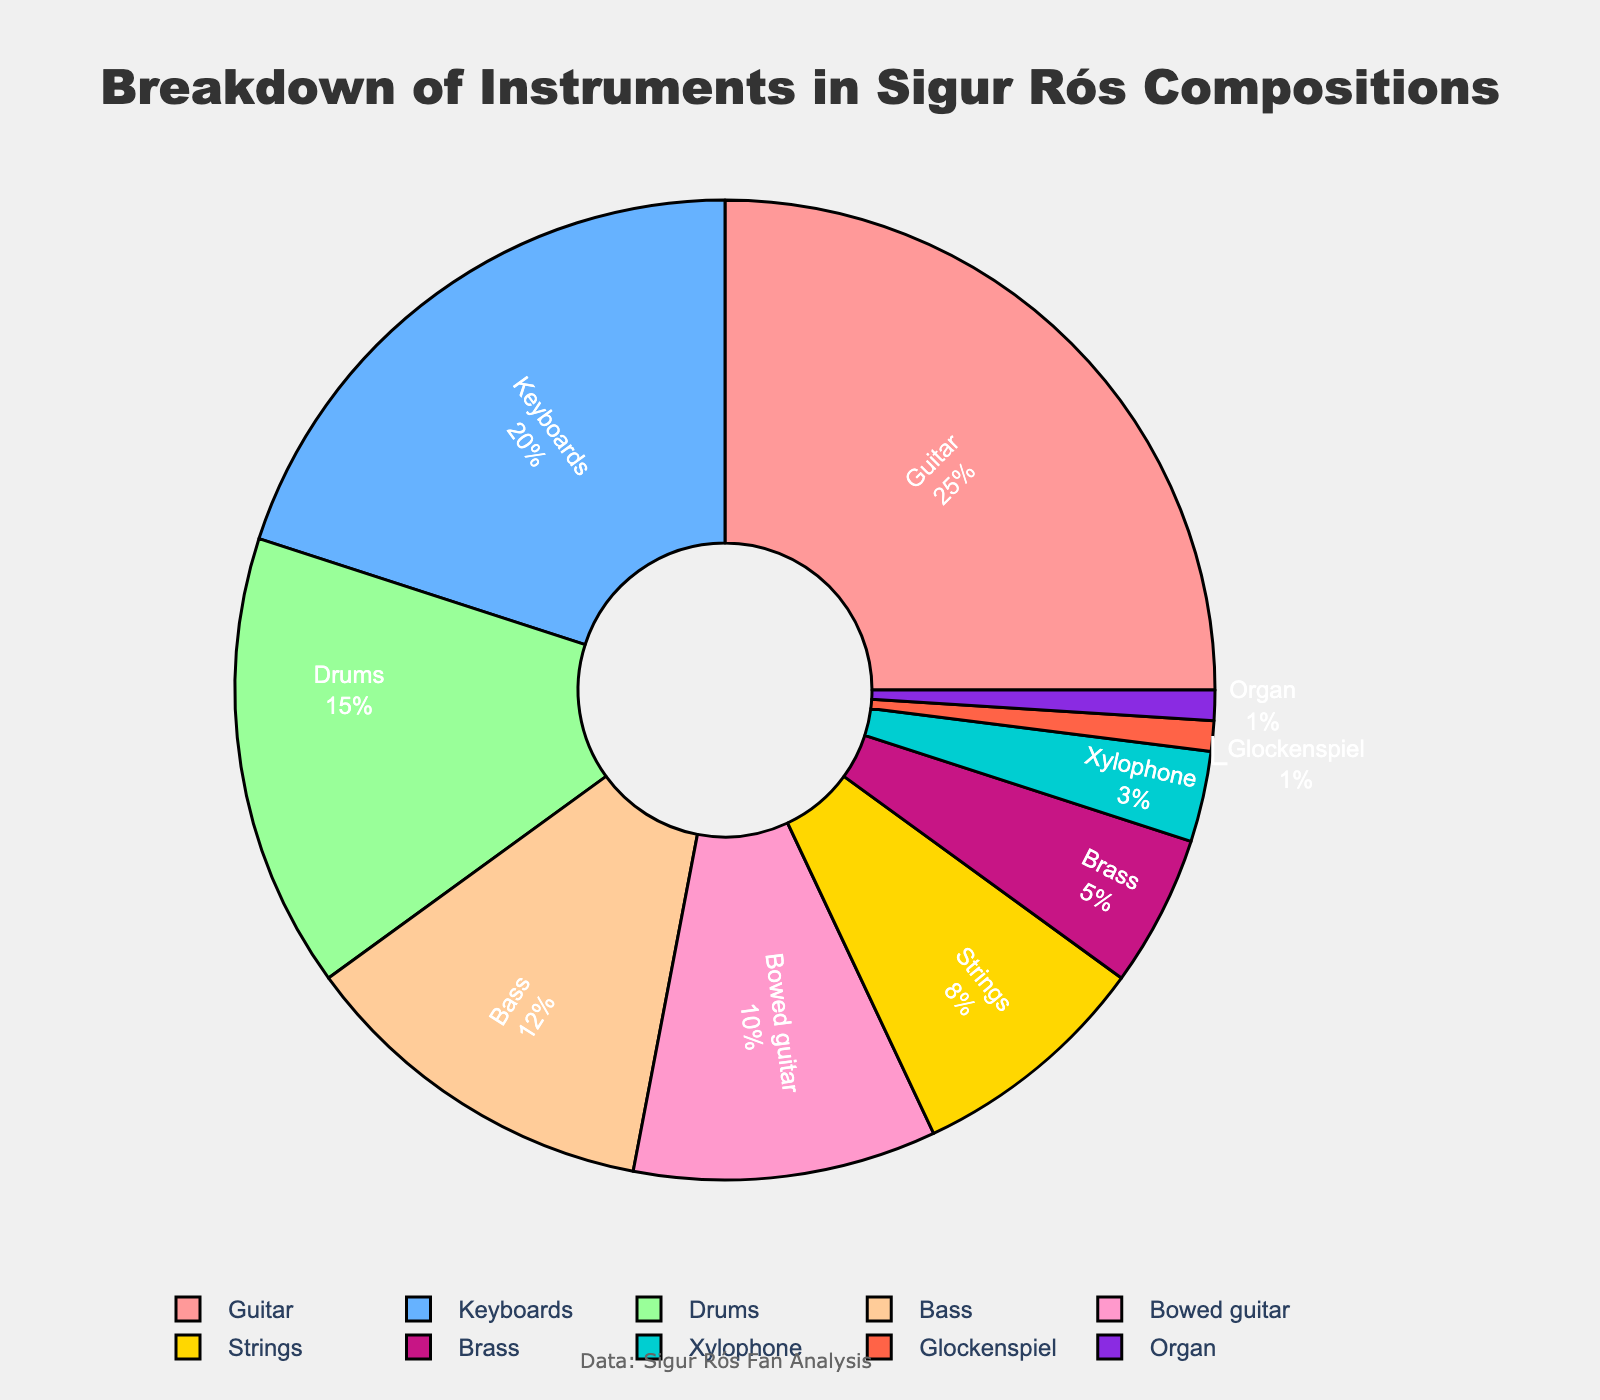what is the combined percentage of guitar and bass in Sigur Rós compositions? First, find the percentage for guitar (25%) and bass (12%). Add these two percentages together: 25% + 12% = 37%
Answer: 37% Which instrument falls between the keyboards and bowed guitar in terms of percentage? From the data, keyboards are at 20%, and bowed guitar is at 10%. The instrument with a percentage of 15%, which falls between these two, is drums
Answer: Drums What is the difference in percentage between the most used and the least used instrument? The most used instrument is guitar at 25%, and the least used instruments are glockenspiel and organ, each at 1%. Subtract the least used from the most used: 25% - 1% = 24%
Answer: 24% Which instrument uses a yellow shaded color? The pie chart assigns specific colors to each segment based on a set of predefined colors. From the assigned colors in the code, the yellow shade is associated with the percentage of the 'Brass' instrument.
Answer: Brass How many instruments have a usage percentage below 10%? From the data, the instruments below 10% are strings (8%), brass (5%), xylophone (3%), glockenspiel (1%), and organ (1%). Counting these gives us 5 instruments.
Answer: 5 Which instrument category has just half the percentage usage of the guitar? Guitar has a usage percentage of 25%. Half of 25% is 12.5%. The closest category to 12.5% is bass, which has 12%.
Answer: Bass Compare the total percentage of the bowed guitar and brass against drums. Which is larger? Bowed guitar and brass percentages are 10% and 5% respectively; combined they form 15%. Drums alone are also at 15%. So both are equal.
Answer: Equal Which instrument percentages together sum up to the total percentage of guitar? Guitar has a percentage of 25%. The instruments bowed guitar (10%), brass (5%), xylophone (3%), glockenspiel (1%), and organ (1%) sum up to 10% + 5% + 3% + 1% + 1% = 20%. Adding strings (8%) would exceed the total percentage.
Answer: No Instrument 